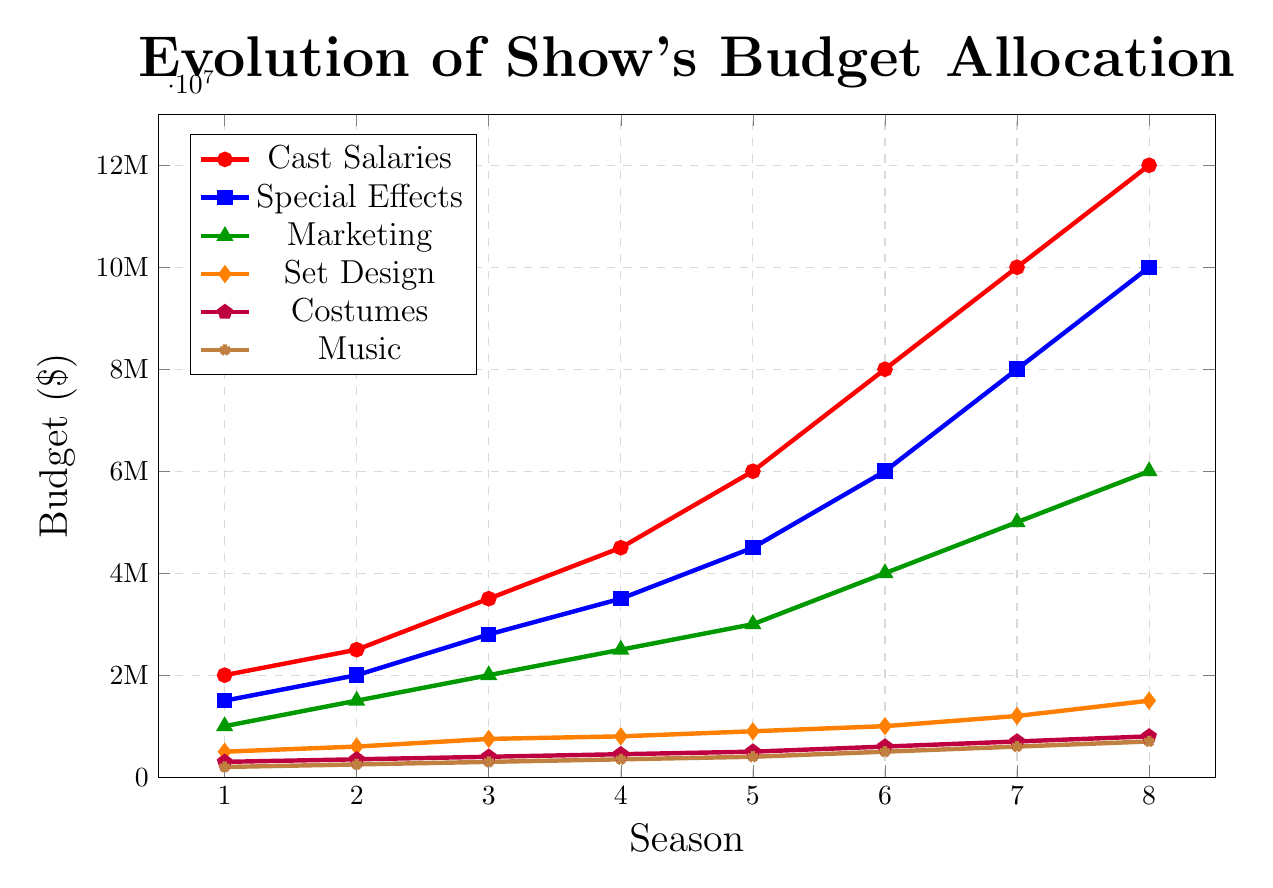What is the budget allocated to Cast Salaries in season 6? Look at the red line with circles. In season 6, it reaches up to $8,000,000.
Answer: $8,000,000 How much did the budget for Special Effects increase from season 4 to season 8? Find the value for Special Effects (blue squares) in season 4 ($3,500,000) and season 8 ($10,000,000). Compute the difference, $10,000,000 - $3,500,000.
Answer: $6,500,000 Compare the budget for Marketing and Set Design in season 5. Which one is higher and by how much? Look at the green triangles for Marketing ($3,000,000) and orange diamonds for Set Design ($900,000) in season 5. Subtract the budget for Set Design from Marketing, $3,000,000 - $900,000.
Answer: Marketing is higher by $2,100,000 What is the total budget for Costumes across all seasons? Sum the values for Costumes (purple pentagons): $300,000 + $350,000 + $400,000 + $450,000 + $500,000 + $600,000 + $700,000 + $800,000.
Answer: $4,100,000 Between which two consecutive seasons did Cast Salaries increase the most? Inspect the increments in the red line with circles:
- Season 1 to 2: $2,500,000 - $2,000,000 = $500,000
- Season 2 to 3: $3,500,000 - $2,500,000 = $1,000,000
- Season 3 to 4: $4,500,000 - $3,500,000 = $1,000,000
- Season 4 to 5: $6,000,000 - $4,500,000 = $1,500,000
- Season 5 to 6: $8,000,000 - $6,000,000 = $2,000,000
- Season 6 to 7: $10,000,000 - $8,000,000 = $2,000,000
- Season 7 to 8: $12,000,000 - $10,000,000 = $2,000,000
Find that the maximum increment is $2,000,000 between seasons 5 to 6, 6 to 7, and 7 to 8.
Answer: Between seasons 5 to 6, 6 to 7, and 7 to 8 How much more is spent on Cast Salaries than Music in season 8? Cast Salaries (red circles) in season 8 is $12,000,000 and Music (brown stars) is $700,000. Subtract the Music budget from the Cast Salaries: $12,000,000 - $700,000.
Answer: $11,300,000 What's the average budget for Special Effects over the 8 seasons? Sum the values for Special Effects (blue squares): $1,500,000 + $2,000,000 + $2,800,000 + $3,500,000 + $4,500,000 + $6,000,000 + $8,000,000 + $10,000,000. Divide by 8 to get the average.
Answer: $4,775,000 How did the budget for Set Design change between season 2 and season 4? Look at the orange diamonds for Set Design in seasons 2 ($600,000) and 4 ($800,000). Subtract the two values: $800,000 - $600,000.
Answer: Increased by $200,000 